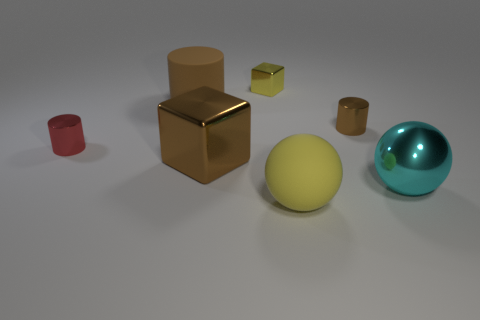Are there fewer red metallic cylinders than large red rubber things?
Your answer should be compact. No. There is a matte object in front of the large cyan metal thing; is it the same shape as the large brown shiny thing?
Offer a very short reply. No. Are any large blue cylinders visible?
Ensure brevity in your answer.  No. There is a rubber cylinder that is to the left of the big metal object left of the shiny cylinder that is on the right side of the red shiny thing; what color is it?
Offer a very short reply. Brown. Are there an equal number of large yellow things that are behind the brown cube and tiny brown shiny things that are right of the cyan sphere?
Your response must be concise. Yes. What is the shape of the cyan metallic thing that is the same size as the yellow matte object?
Keep it short and to the point. Sphere. Are there any large rubber things that have the same color as the small cube?
Your answer should be compact. Yes. The tiny object that is to the left of the large cylinder has what shape?
Offer a very short reply. Cylinder. What is the color of the tiny metallic block?
Offer a terse response. Yellow. There is another cylinder that is the same material as the tiny brown cylinder; what color is it?
Make the answer very short. Red. 